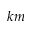<formula> <loc_0><loc_0><loc_500><loc_500>k m</formula> 